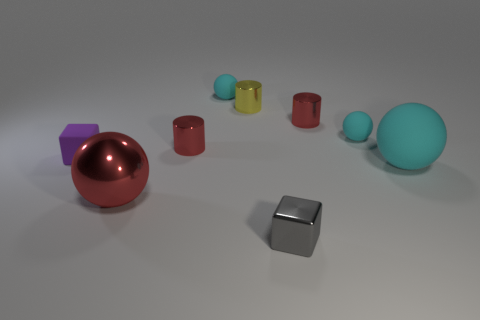Is the number of metal spheres behind the big matte ball less than the number of big red metallic spheres?
Offer a terse response. Yes. Do the large shiny thing and the yellow thing have the same shape?
Keep it short and to the point. No. What size is the block that is made of the same material as the large cyan sphere?
Ensure brevity in your answer.  Small. Are there fewer small yellow rubber cubes than metallic things?
Give a very brief answer. Yes. How many tiny things are matte things or gray shiny cylinders?
Your answer should be very brief. 3. How many matte spheres are both behind the tiny purple rubber cube and in front of the tiny yellow object?
Provide a succinct answer. 1. Are there more large red shiny blocks than tiny shiny objects?
Make the answer very short. No. What number of other things are the same shape as the yellow metal thing?
Give a very brief answer. 2. Does the tiny matte cube have the same color as the large metal ball?
Your response must be concise. No. What is the material of the thing that is both in front of the large matte object and left of the small yellow thing?
Your answer should be very brief. Metal. 